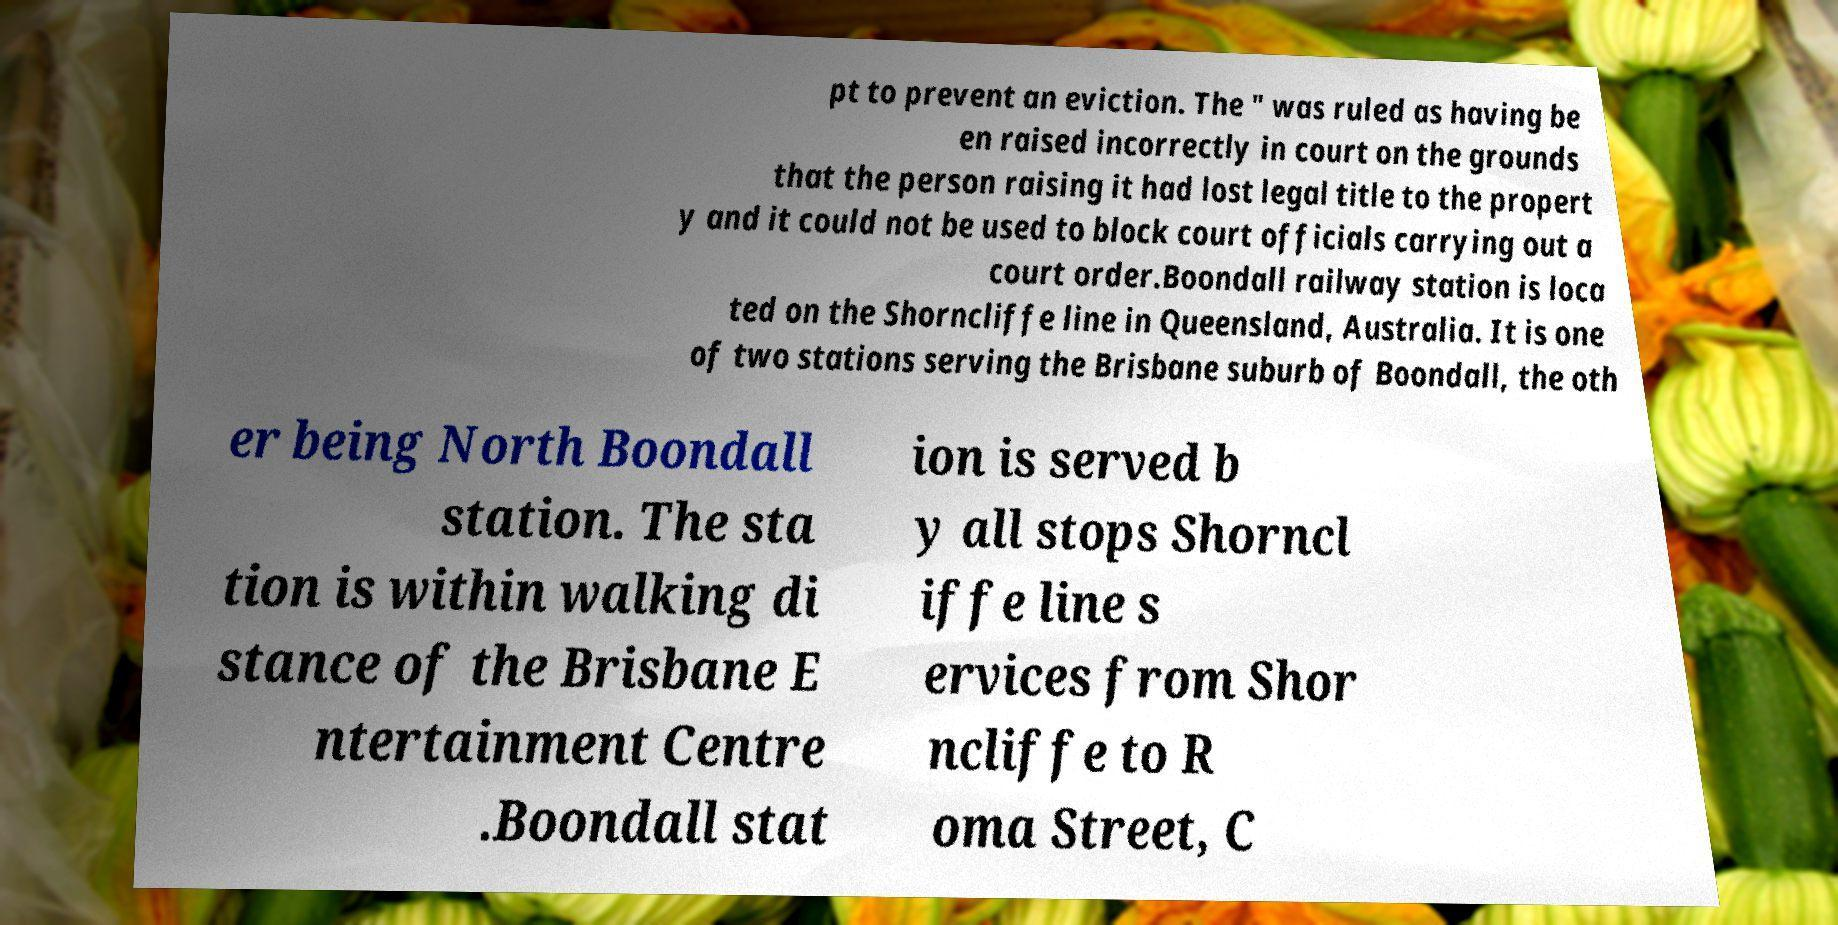Can you accurately transcribe the text from the provided image for me? pt to prevent an eviction. The " was ruled as having be en raised incorrectly in court on the grounds that the person raising it had lost legal title to the propert y and it could not be used to block court officials carrying out a court order.Boondall railway station is loca ted on the Shorncliffe line in Queensland, Australia. It is one of two stations serving the Brisbane suburb of Boondall, the oth er being North Boondall station. The sta tion is within walking di stance of the Brisbane E ntertainment Centre .Boondall stat ion is served b y all stops Shorncl iffe line s ervices from Shor ncliffe to R oma Street, C 